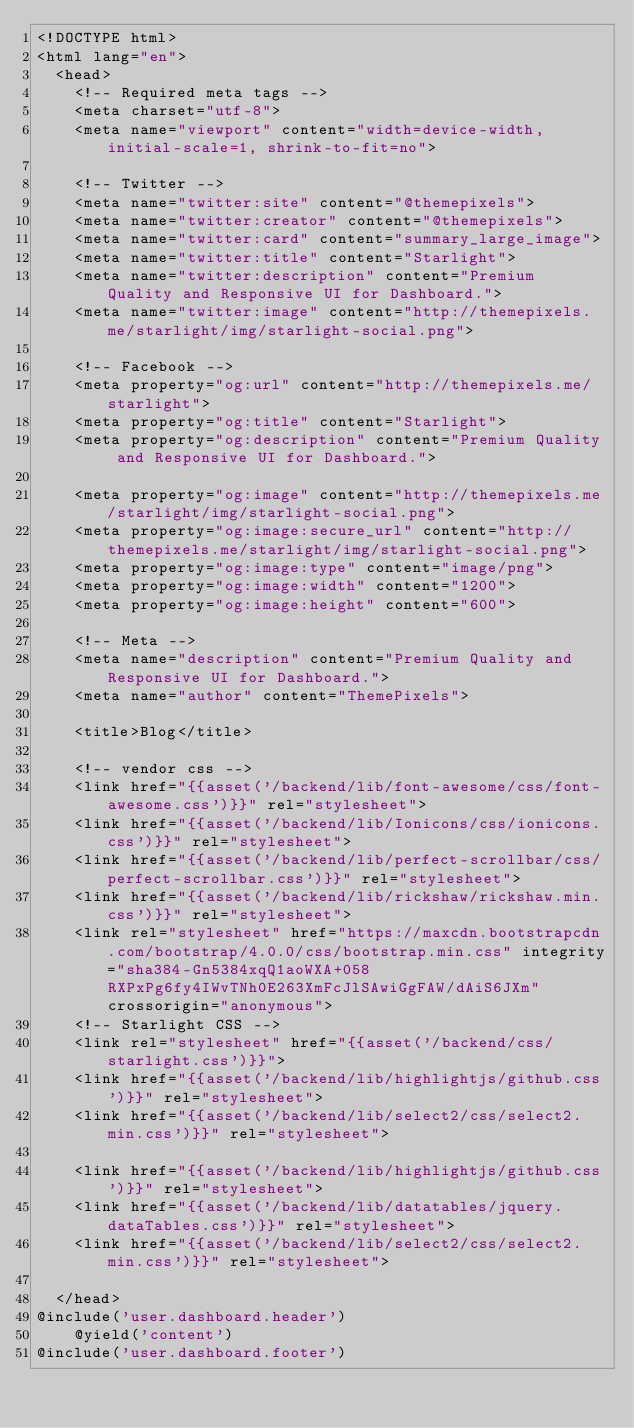<code> <loc_0><loc_0><loc_500><loc_500><_PHP_><!DOCTYPE html>
<html lang="en">
  <head>
    <!-- Required meta tags -->
    <meta charset="utf-8">
    <meta name="viewport" content="width=device-width, initial-scale=1, shrink-to-fit=no">

    <!-- Twitter -->
    <meta name="twitter:site" content="@themepixels">
    <meta name="twitter:creator" content="@themepixels">
    <meta name="twitter:card" content="summary_large_image">
    <meta name="twitter:title" content="Starlight">
    <meta name="twitter:description" content="Premium Quality and Responsive UI for Dashboard.">
    <meta name="twitter:image" content="http://themepixels.me/starlight/img/starlight-social.png">

    <!-- Facebook -->
    <meta property="og:url" content="http://themepixels.me/starlight">
    <meta property="og:title" content="Starlight">
    <meta property="og:description" content="Premium Quality and Responsive UI for Dashboard.">

    <meta property="og:image" content="http://themepixels.me/starlight/img/starlight-social.png">
    <meta property="og:image:secure_url" content="http://themepixels.me/starlight/img/starlight-social.png">
    <meta property="og:image:type" content="image/png">
    <meta property="og:image:width" content="1200">
    <meta property="og:image:height" content="600">

    <!-- Meta -->
    <meta name="description" content="Premium Quality and Responsive UI for Dashboard.">
    <meta name="author" content="ThemePixels">

    <title>Blog</title>

    <!-- vendor css -->
    <link href="{{asset('/backend/lib/font-awesome/css/font-awesome.css')}}" rel="stylesheet">
    <link href="{{asset('/backend/lib/Ionicons/css/ionicons.css')}}" rel="stylesheet">
    <link href="{{asset('/backend/lib/perfect-scrollbar/css/perfect-scrollbar.css')}}" rel="stylesheet">
    <link href="{{asset('/backend/lib/rickshaw/rickshaw.min.css')}}" rel="stylesheet">
    <link rel="stylesheet" href="https://maxcdn.bootstrapcdn.com/bootstrap/4.0.0/css/bootstrap.min.css" integrity="sha384-Gn5384xqQ1aoWXA+058RXPxPg6fy4IWvTNh0E263XmFcJlSAwiGgFAW/dAiS6JXm" crossorigin="anonymous">
    <!-- Starlight CSS -->
    <link rel="stylesheet" href="{{asset('/backend/css/starlight.css')}}">
    <link href="{{asset('/backend/lib/highlightjs/github.css')}}" rel="stylesheet">
    <link href="{{asset('/backend/lib/select2/css/select2.min.css')}}" rel="stylesheet">

    <link href="{{asset('/backend/lib/highlightjs/github.css')}}" rel="stylesheet">
    <link href="{{asset('/backend/lib/datatables/jquery.dataTables.css')}}" rel="stylesheet">
    <link href="{{asset('/backend/lib/select2/css/select2.min.css')}}" rel="stylesheet">

  </head>
@include('user.dashboard.header')
    @yield('content')
@include('user.dashboard.footer')</code> 